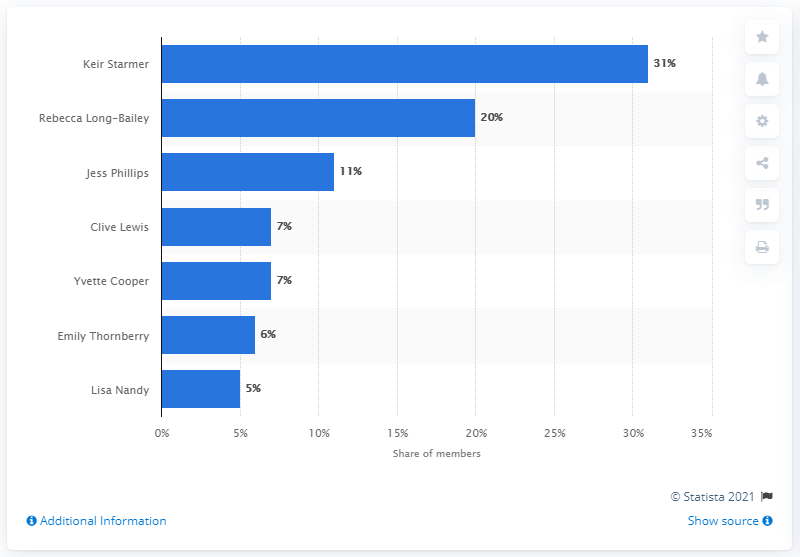Point out several critical features in this image. Keir Starmer emerged as the leading candidate to succeed Jeremy Corbyn as the leader of the United Kingdom's Labour party in 2020. 